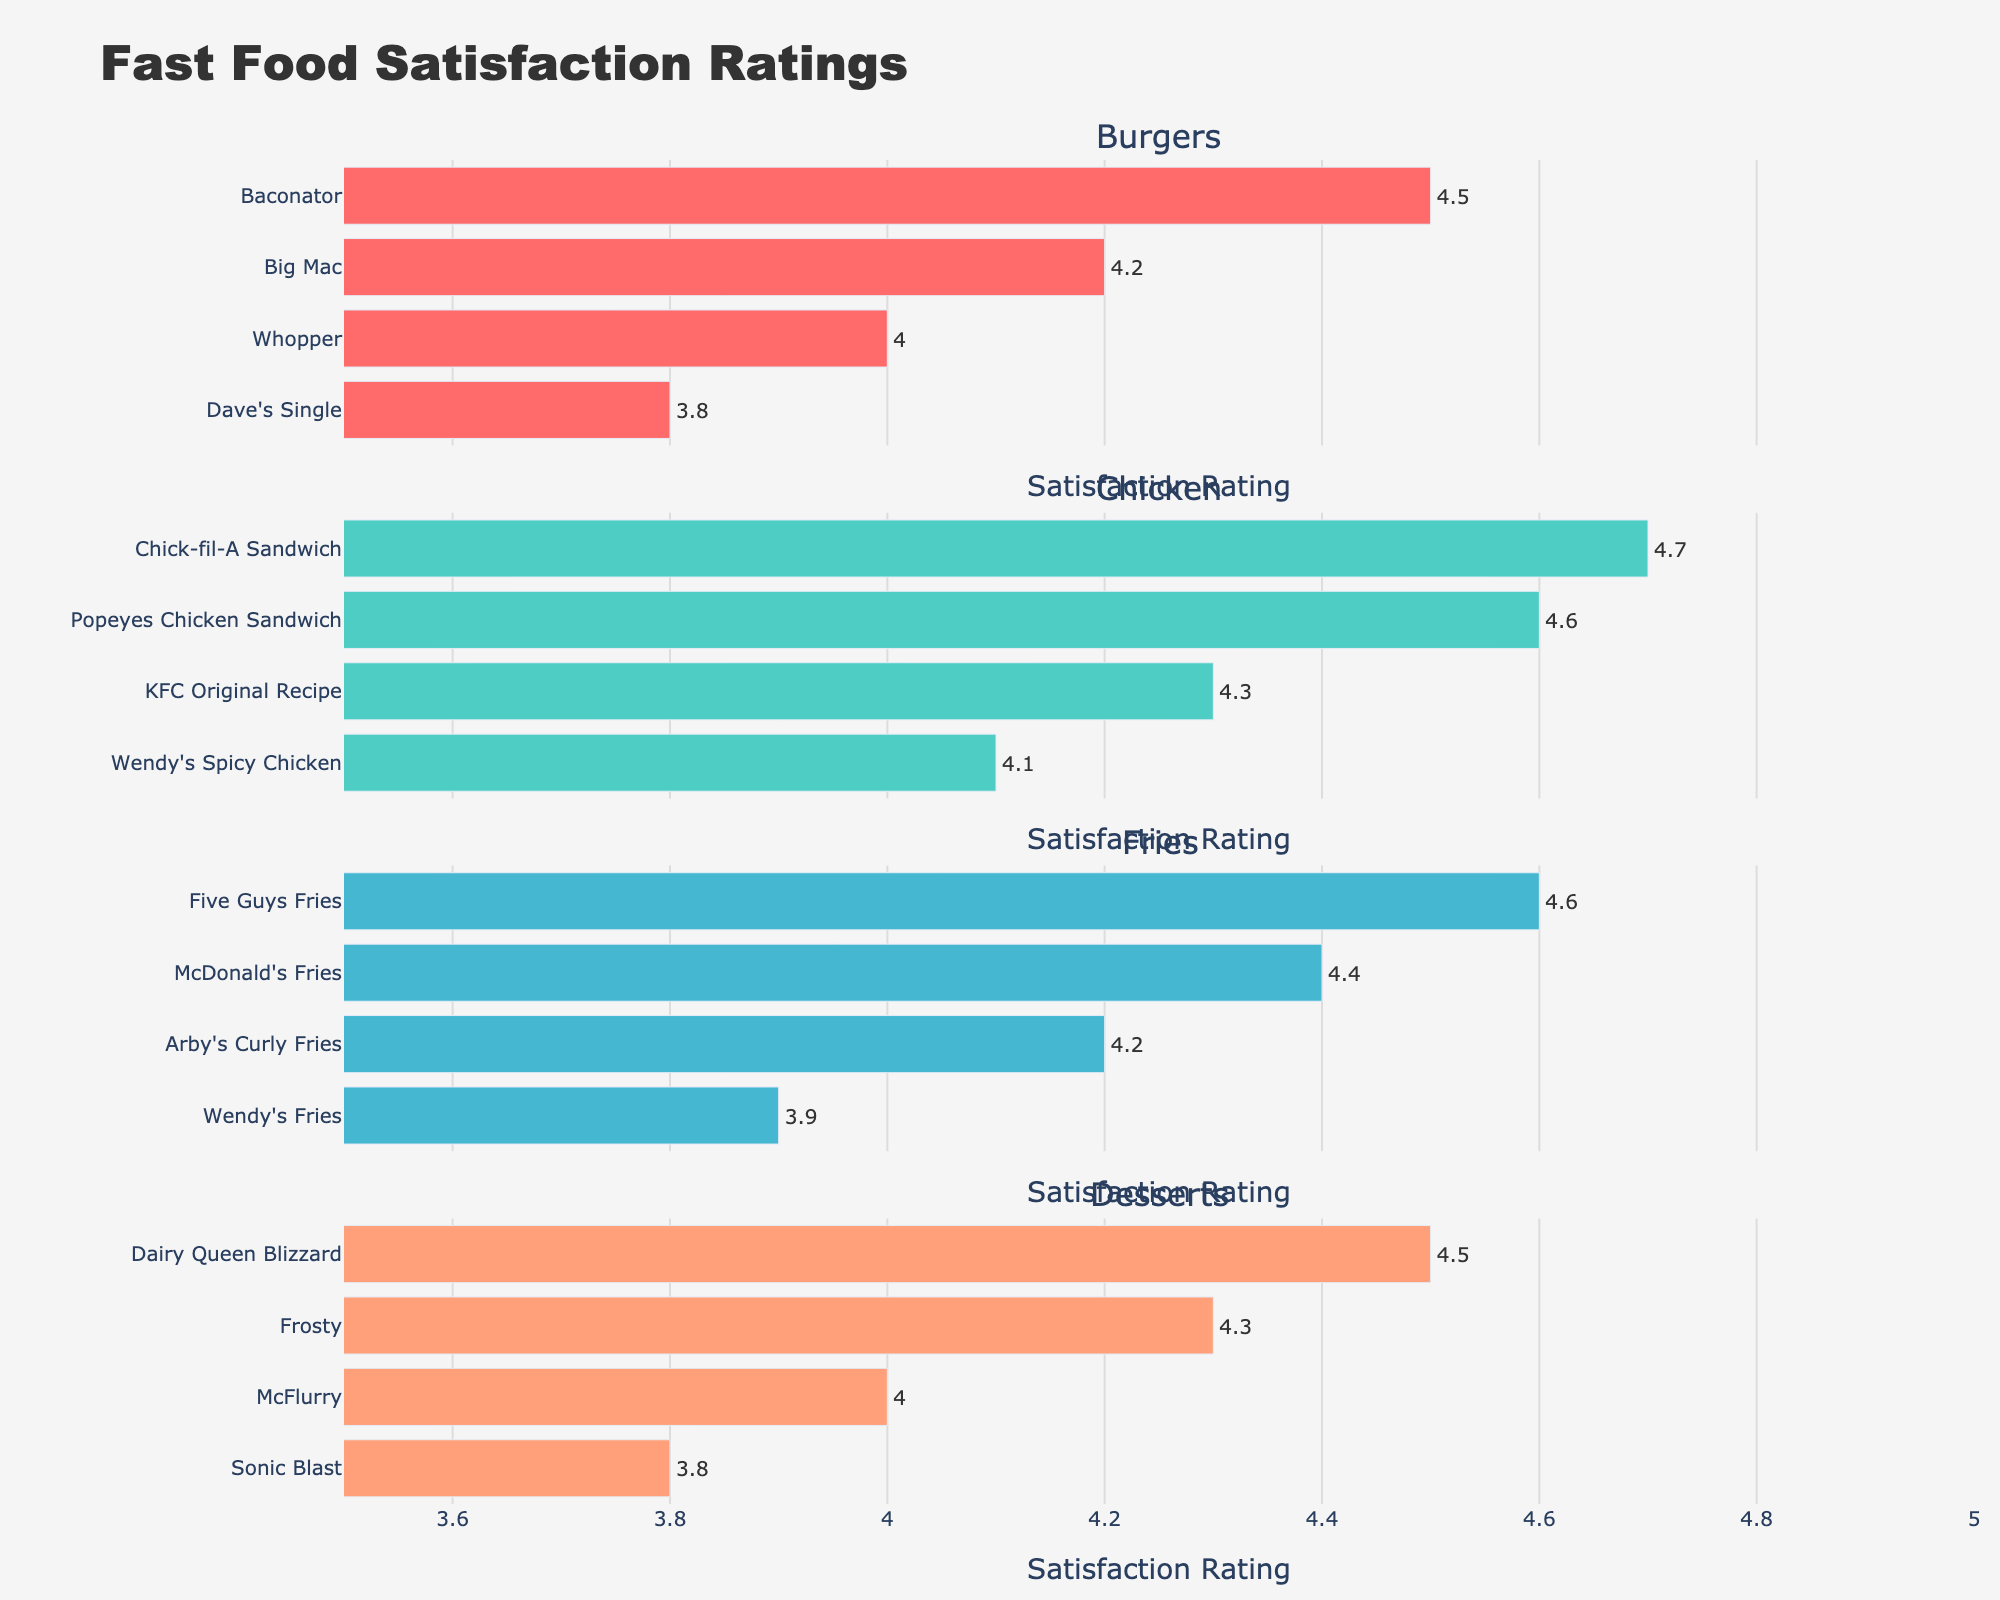Which category has the item with the highest satisfaction rating? In the figure, you can see that the Chick-fil-A Sandwich in the Chicken category has the highest rating at 4.7.
Answer: Chicken How many items are shown in the Burgers category? By counting the bars in the subplot for Burgers, there are 4 items: Big Mac, Whopper, Dave's Single, and Baconator.
Answer: 4 What is the satisfaction rating for the Wendy's Spicy Chicken? By locating Wendy's Spicy Chicken in the Chicken subplot, we see its satisfaction rating is marked at 4.1.
Answer: 4.1 Which item has a higher satisfaction rating: McDonald's Fries or Five Guys Fries? Comparing the bars for McDonald's Fries and Five Guys Fries in the Fries subplot, Five Guys Fries has a higher rating of 4.6 compared to McDonald's Fries at 4.4.
Answer: Five Guys Fries What is the median satisfaction rating for the Desserts category? There are 4 items in the Desserts category, so the median is the average of the 2nd and 3rd ratings. The ratings are 3.8, 4.0, 4.3, and 4.5. The median is (4.0 + 4.3) / 2 = 4.15.
Answer: 4.15 Which items have a satisfaction rating of 4.5? Check each subplot to identify items with a bar reaching the 4.5 mark: Baconator in Burgers and Dairy Queen Blizzard in Desserts.
Answer: Baconator, Dairy Queen Blizzard Compare the highest-rated item in the Burgers category with the highest-rated item in the Chicken category. Which one is higher? The highest-rated item in the Burgers category is Baconator at 4.5, and in the Chicken category, it is Chick-fil-A Sandwich at 4.7. The Chick-fil-A Sandwich has a higher rating.
Answer: Chick-fil-A Sandwich Which category has the most uniform distribution of ratings (i.e., the least variation)? In ratios, a visual observation of the range of the bars in the subplots shows the Burgers category has ratings from 3.8 to 4.5 while Desserts range from 3.8 to 4.5. Fries also range from 3.9 to 4.6, and Chicken from 4.1 to 4.7. Desserts seem to have the least variation.
Answer: Desserts What is the average satisfaction rating of items in the Fries category? Sum the satisfaction ratings for Fries (4.4 + 4.6 + 4.2 + 3.9) = 17.1. There are 4 items, so the average is 17.1 / 4 = 4.275.
Answer: 4.275 